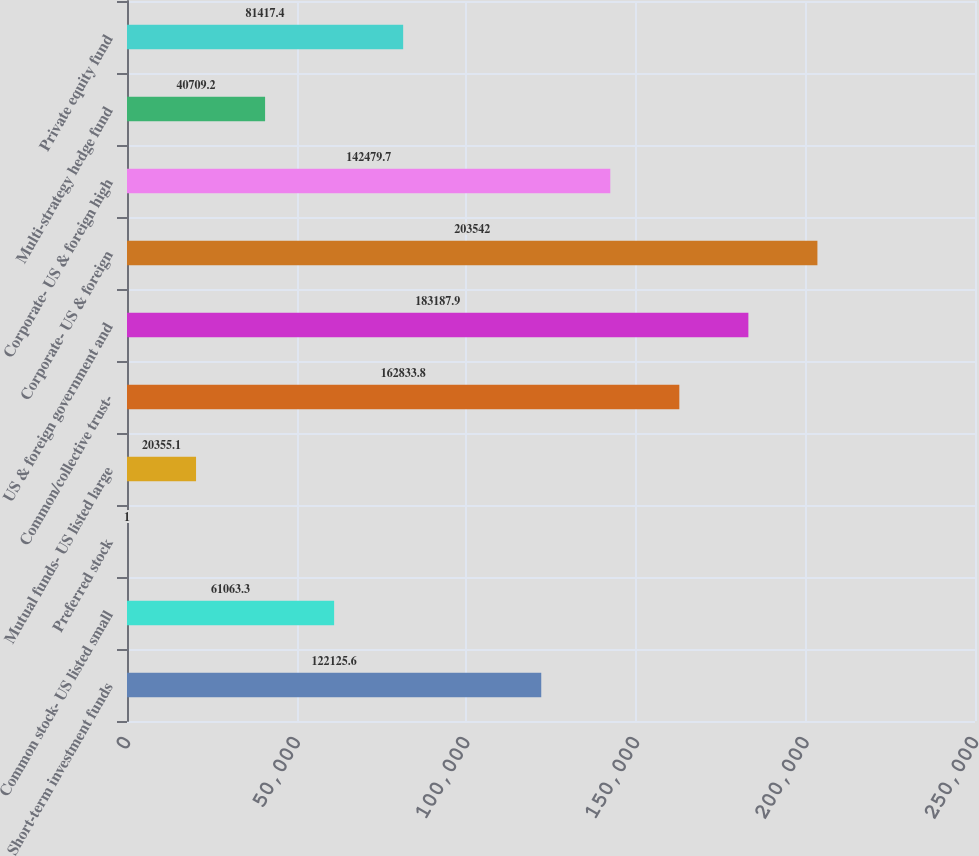<chart> <loc_0><loc_0><loc_500><loc_500><bar_chart><fcel>Short-term investment funds<fcel>Common stock- US listed small<fcel>Preferred stock<fcel>Mutual funds- US listed large<fcel>Common/collective trust-<fcel>US & foreign government and<fcel>Corporate- US & foreign<fcel>Corporate- US & foreign high<fcel>Multi-strategy hedge fund<fcel>Private equity fund<nl><fcel>122126<fcel>61063.3<fcel>1<fcel>20355.1<fcel>162834<fcel>183188<fcel>203542<fcel>142480<fcel>40709.2<fcel>81417.4<nl></chart> 